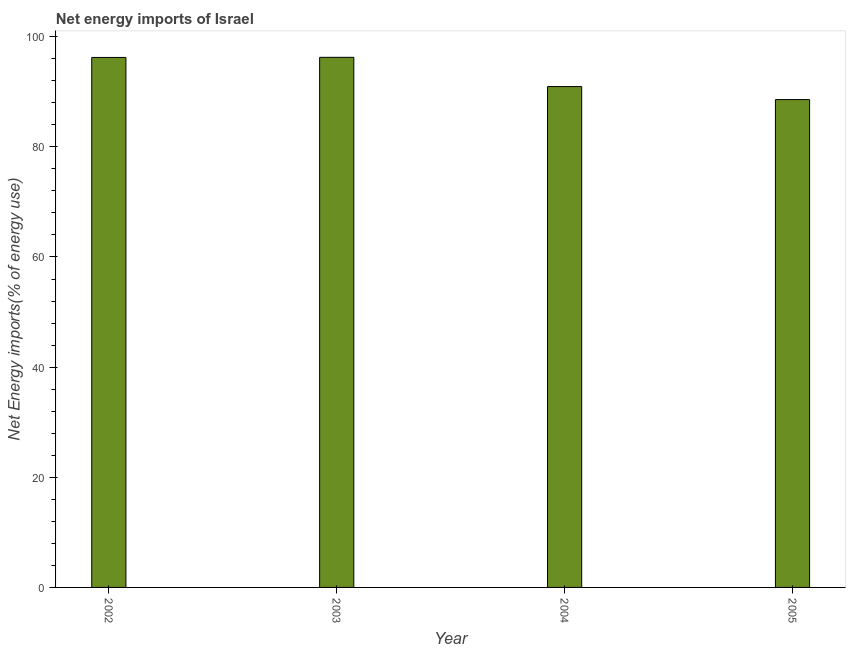Does the graph contain any zero values?
Offer a terse response. No. What is the title of the graph?
Your response must be concise. Net energy imports of Israel. What is the label or title of the X-axis?
Provide a short and direct response. Year. What is the label or title of the Y-axis?
Provide a succinct answer. Net Energy imports(% of energy use). What is the energy imports in 2005?
Your response must be concise. 88.58. Across all years, what is the maximum energy imports?
Keep it short and to the point. 96.26. Across all years, what is the minimum energy imports?
Ensure brevity in your answer.  88.58. What is the sum of the energy imports?
Provide a short and direct response. 372.02. What is the difference between the energy imports in 2002 and 2005?
Your answer should be very brief. 7.65. What is the average energy imports per year?
Your answer should be very brief. 93. What is the median energy imports?
Make the answer very short. 93.59. What is the ratio of the energy imports in 2002 to that in 2004?
Your answer should be compact. 1.06. Is the energy imports in 2002 less than that in 2005?
Offer a very short reply. No. What is the difference between the highest and the second highest energy imports?
Provide a succinct answer. 0.02. Is the sum of the energy imports in 2002 and 2005 greater than the maximum energy imports across all years?
Offer a very short reply. Yes. What is the difference between the highest and the lowest energy imports?
Your response must be concise. 7.67. In how many years, is the energy imports greater than the average energy imports taken over all years?
Make the answer very short. 2. How many bars are there?
Offer a terse response. 4. Are the values on the major ticks of Y-axis written in scientific E-notation?
Offer a very short reply. No. What is the Net Energy imports(% of energy use) of 2002?
Make the answer very short. 96.23. What is the Net Energy imports(% of energy use) in 2003?
Offer a very short reply. 96.26. What is the Net Energy imports(% of energy use) of 2004?
Make the answer very short. 90.95. What is the Net Energy imports(% of energy use) of 2005?
Give a very brief answer. 88.58. What is the difference between the Net Energy imports(% of energy use) in 2002 and 2003?
Ensure brevity in your answer.  -0.02. What is the difference between the Net Energy imports(% of energy use) in 2002 and 2004?
Your answer should be very brief. 5.29. What is the difference between the Net Energy imports(% of energy use) in 2002 and 2005?
Keep it short and to the point. 7.65. What is the difference between the Net Energy imports(% of energy use) in 2003 and 2004?
Your answer should be compact. 5.31. What is the difference between the Net Energy imports(% of energy use) in 2003 and 2005?
Your answer should be very brief. 7.67. What is the difference between the Net Energy imports(% of energy use) in 2004 and 2005?
Offer a very short reply. 2.36. What is the ratio of the Net Energy imports(% of energy use) in 2002 to that in 2004?
Make the answer very short. 1.06. What is the ratio of the Net Energy imports(% of energy use) in 2002 to that in 2005?
Your answer should be very brief. 1.09. What is the ratio of the Net Energy imports(% of energy use) in 2003 to that in 2004?
Make the answer very short. 1.06. What is the ratio of the Net Energy imports(% of energy use) in 2003 to that in 2005?
Offer a very short reply. 1.09. 